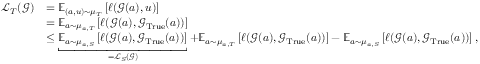<formula> <loc_0><loc_0><loc_500><loc_500>\begin{array} { r l } { \mathcal { L } _ { T } ( \mathcal { G } ) } & { = \mathbb { E } _ { ( a , u ) \sim \mu _ { T } } \left [ \ell ( \mathcal { G } ( a ) , u ) \right ] } \\ & { = \mathbb { E } _ { a \sim \mu _ { a , T } } \left [ \ell ( \mathcal { G } ( a ) , \mathcal { G } _ { T r u e } ( a ) ) \right ] } \\ & { \leq \underbracket { \mathbb { E } _ { a \sim \mu _ { a , S } } \left [ \ell ( \mathcal { G } ( a ) , \mathcal { G } _ { T r u e } ( a ) ) \right ] } _ { = \mathcal { L } _ { S } ( \mathcal { G } ) } + \mathbb { E } _ { a \sim \mu _ { a , T } } \left [ \ell ( \mathcal { G } ( a ) , \mathcal { G } _ { T r u e } ( a ) ) \right ] - \mathbb { E } _ { a \sim \mu _ { a , S } } \left [ \ell ( \mathcal { G } ( a ) , \mathcal { G } _ { T r u e } ( a ) ) \right ] , } \end{array}</formula> 